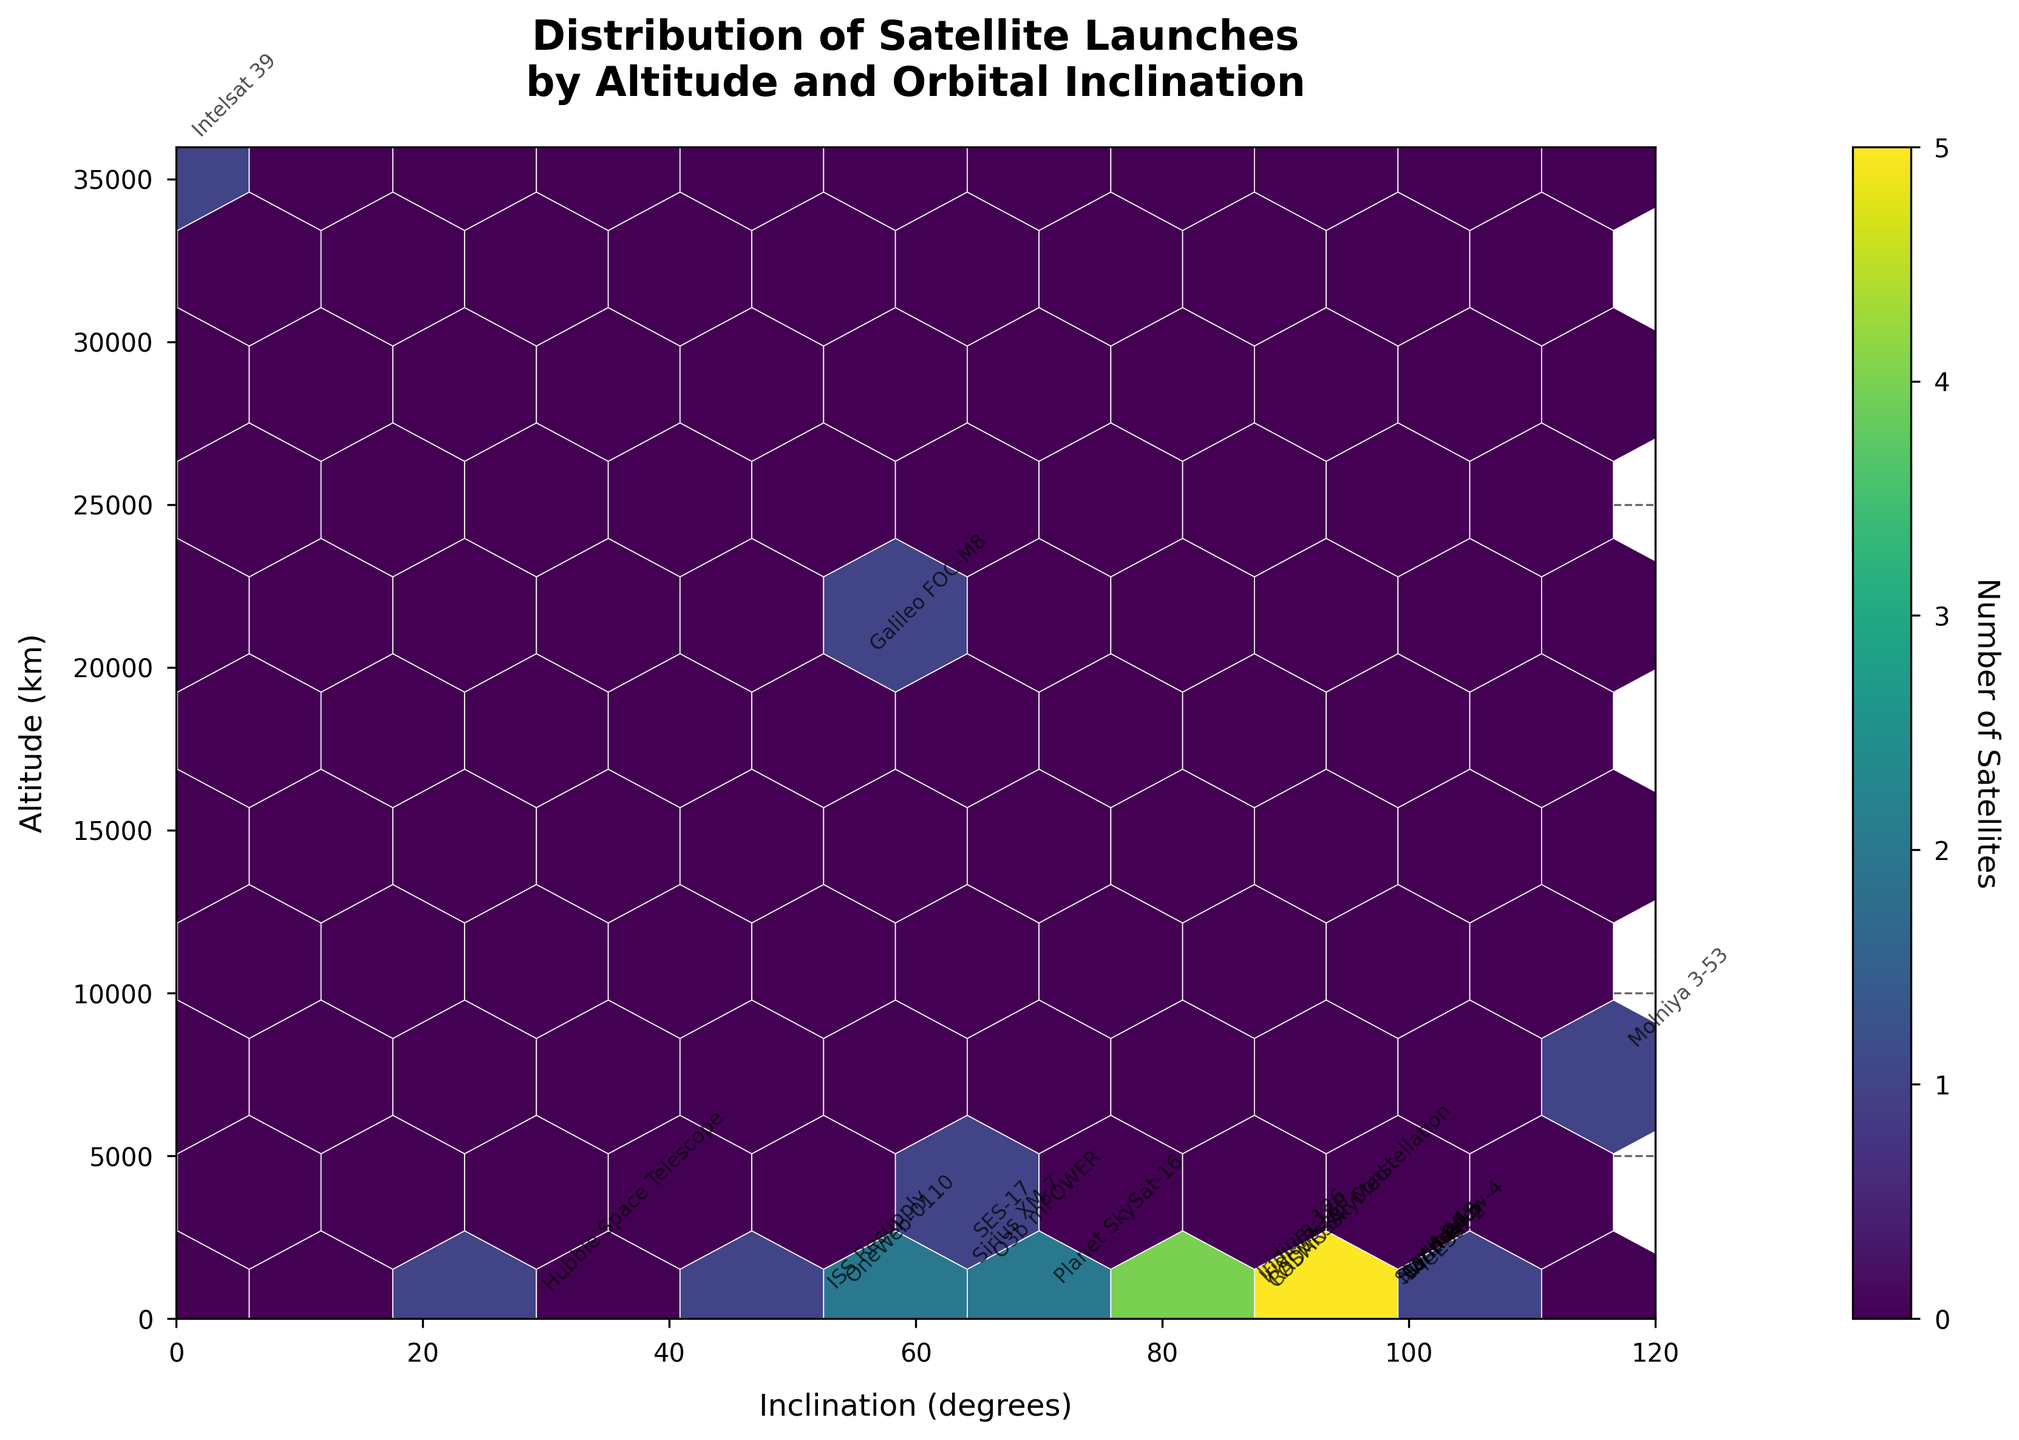How many satellites are displayed in the figure? The figure shows a total of 19 satellites as annotated by their names. Each name represents a satellite.
Answer: 19 What do the two axes represent in the figure? The x-axis represents the orbital inclination in degrees, while the y-axis represents the altitude in kilometers. These labels can be seen directly on the axes.
Answer: The x-axis is orbital inclination and the y-axis is altitude Which satellite is at the highest altitude? The satellite with the highest altitude is annotated with its name, positioned at the top-most part of the plot. This is "Intelsat 39" at 35,786 km.
Answer: Intelsat 39 Among the displayed satellites, which one has the smallest inclination? The satellite with the smallest inclination is positioned closest to the left-most part of the plot, annotating "Intelsat 39" at 0.1 degrees.
Answer: Intelsat 39 What is the most densely populated with satellites region in terms of inclination range? The color intensity in a hexbin plot represents the density. The inclination range around 98 degrees is where the hexbins are darkest, indicating the highest satellite density.
Answer: Around 98 degrees What is the range of altitudes for satellites with inclinations between 80 and 100 degrees? To find this, look at the x-axis range of 80 to 100 degrees and note the y-axis (altitude) values that are annotated within this range. The altitudes range from 450 km to 1000 km.
Answer: 450 km to 1000 km Which satellite has an inclination of approximately 65 degrees and what is its altitude? Look for a satellite name annotated around 65 degrees on the x-axis. This is "O3b mPOWER" at approximately 1336 km altitude.
Answer: O3b mPOWER, 1336 km For satellites in the lower altitude range below 1000 km, what is the inclination range observed? By identifying satellites positioned below 1000 km on the y-axis, we can see they have inclinations ranging from about 28.5 degrees to 99.5 degrees.
Answer: 28.5 to 99.5 degrees Comparing "Starlink-1" and "Molniya 3-53", which satellite is at a higher altitude and by how much? Find the altitudes of both. "Starlink-1" is at 550 km and "Molniya 3-53" is at 7828 km. Subtract the two values to find the difference: 7828 - 550 = 7278 km.
Answer: Molniya 3-53 by 7278 km Are there more satellites with inclinations above or below 60 degrees? Count the annotated satellites on both sides of the 60-degree mark on the x-axis. There are more satellites above 60 degrees.
Answer: More above 60 degrees 